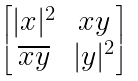<formula> <loc_0><loc_0><loc_500><loc_500>\begin{bmatrix} | x | ^ { 2 } & x y \\ \overline { x y } & | y | ^ { 2 } \end{bmatrix}</formula> 